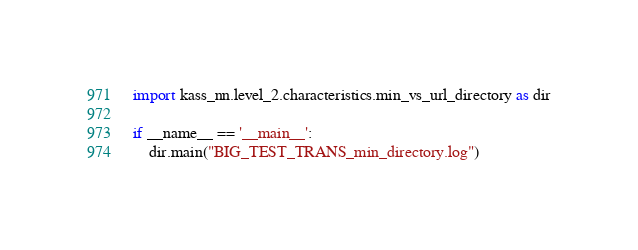Convert code to text. <code><loc_0><loc_0><loc_500><loc_500><_Python_>import kass_nn.level_2.characteristics.min_vs_url_directory as dir

if __name__ == '__main__':
    dir.main("BIG_TEST_TRANS_min_directory.log")</code> 